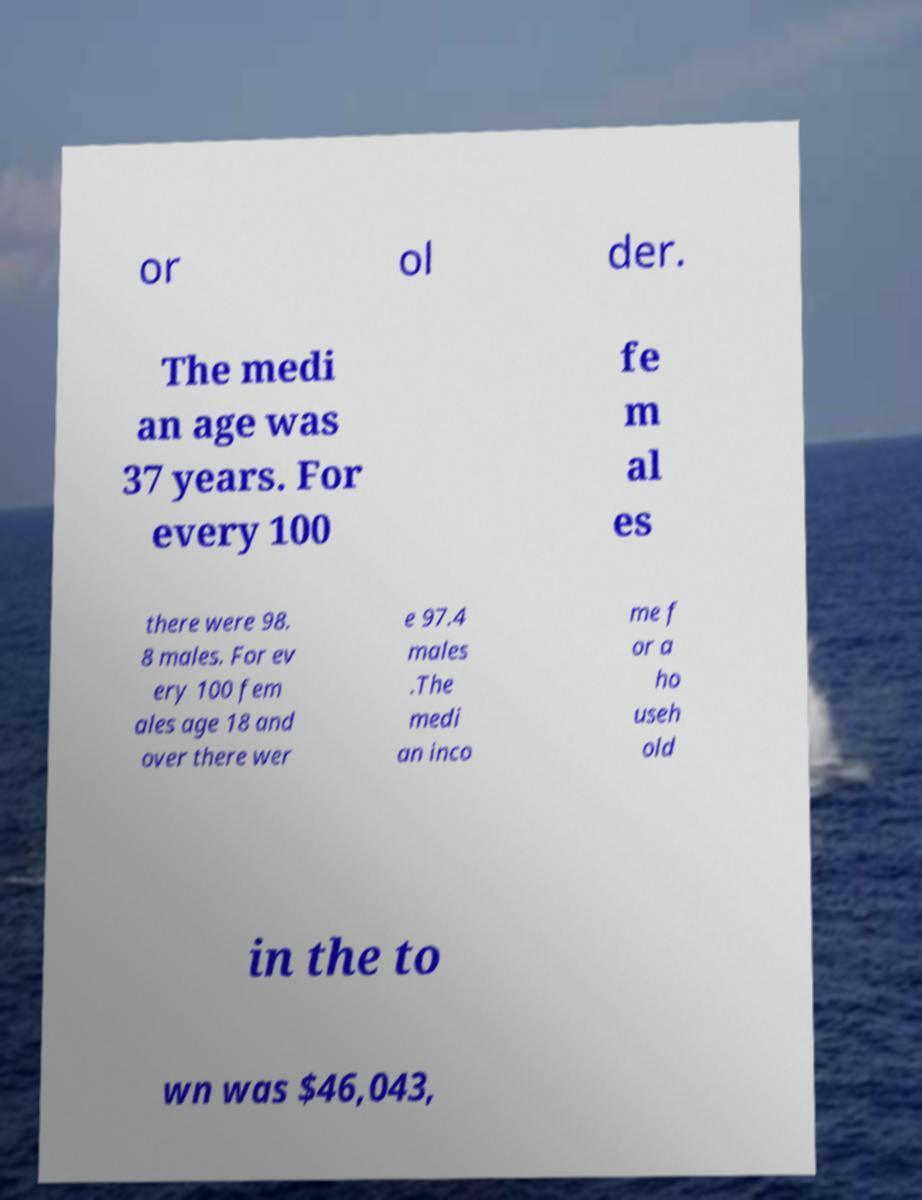What messages or text are displayed in this image? I need them in a readable, typed format. or ol der. The medi an age was 37 years. For every 100 fe m al es there were 98. 8 males. For ev ery 100 fem ales age 18 and over there wer e 97.4 males .The medi an inco me f or a ho useh old in the to wn was $46,043, 